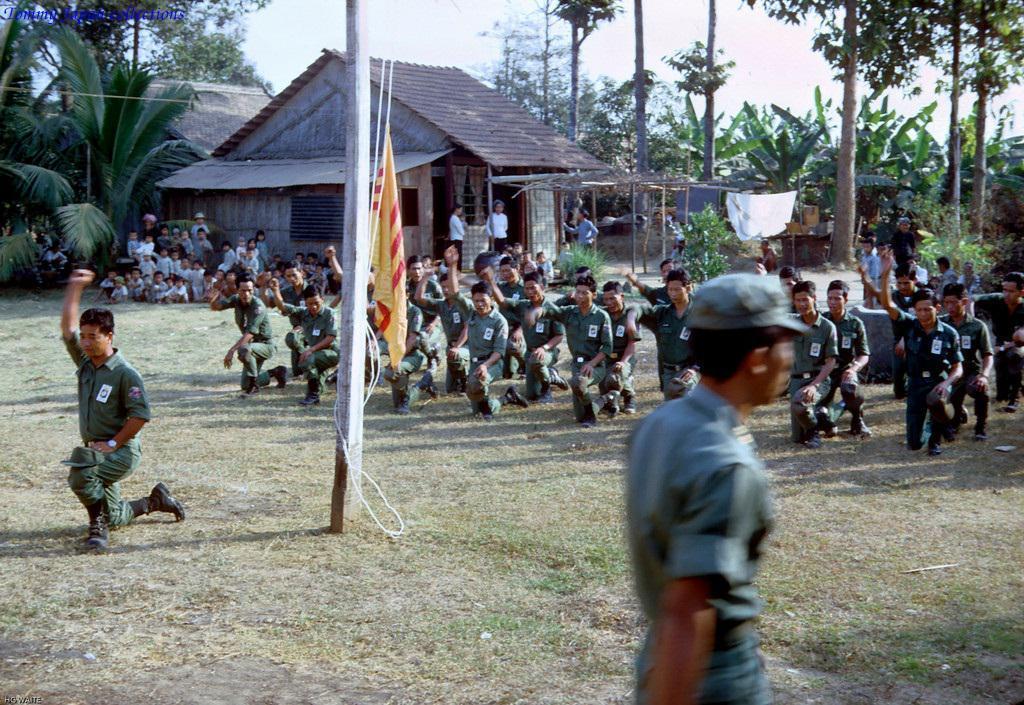How would you summarize this image in a sentence or two? In this image I can see some people in the center of the image kneel down, on the left side of the image I can see some kids sitting and watching these people, at the top of the image I can see a house and some plants and some trees on the left top corner I can see some trees. In the center of the image I can see a pole with a flag.  